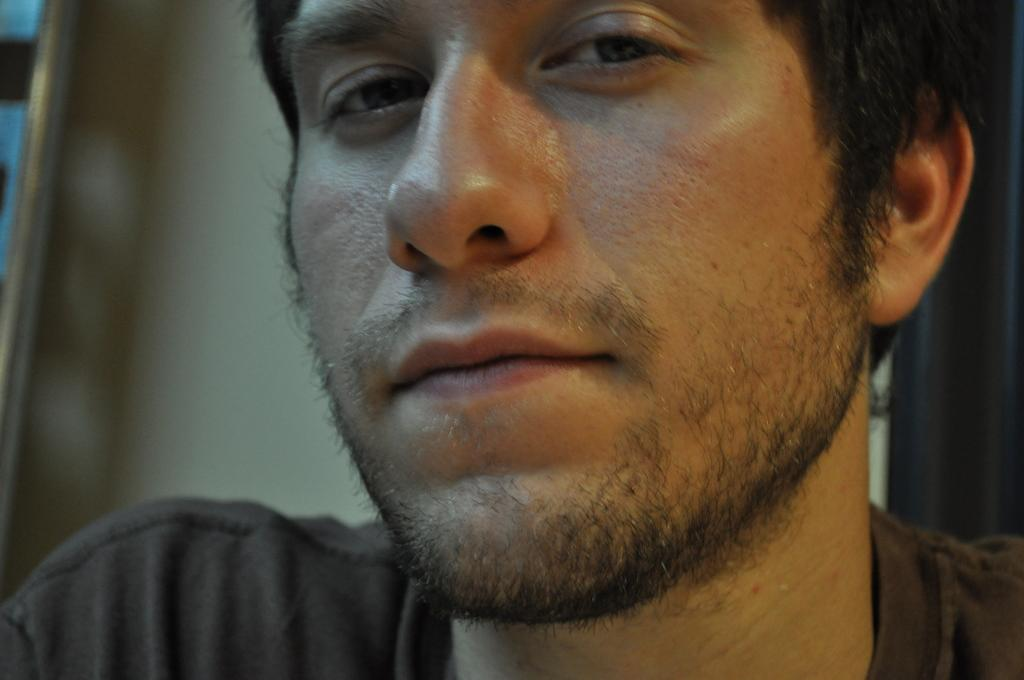Who is present in the image? There is a man in the image. What is the man wearing in the image? The man is wearing a T-shirt. What type of soup is the man eating in the image? There is no soup present in the image; the man is wearing a T-shirt. 